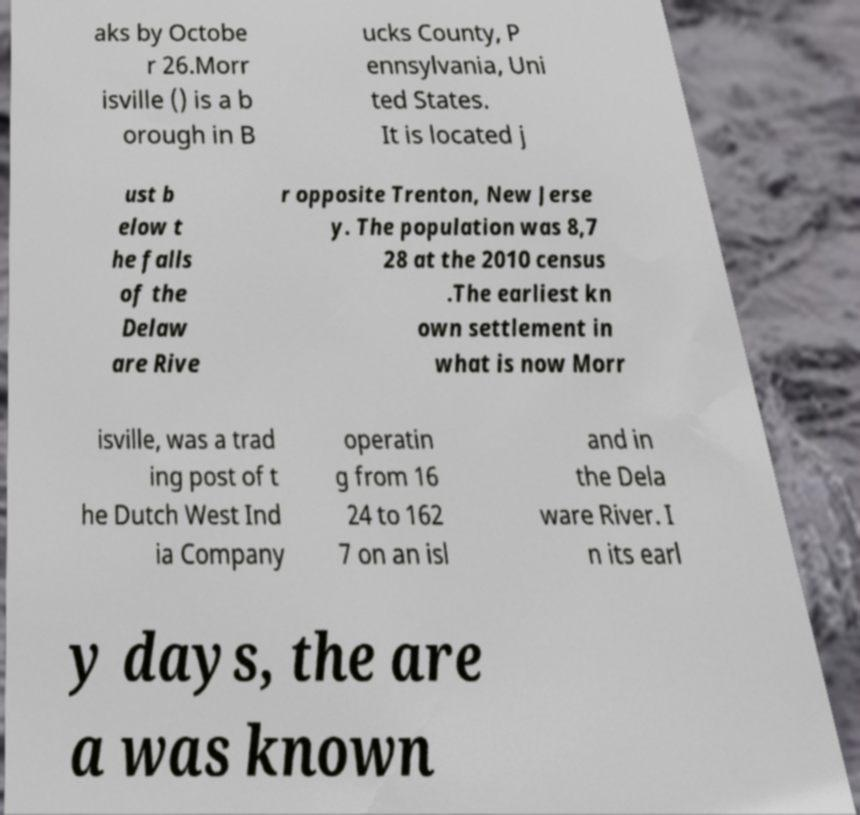Could you assist in decoding the text presented in this image and type it out clearly? aks by Octobe r 26.Morr isville () is a b orough in B ucks County, P ennsylvania, Uni ted States. It is located j ust b elow t he falls of the Delaw are Rive r opposite Trenton, New Jerse y. The population was 8,7 28 at the 2010 census .The earliest kn own settlement in what is now Morr isville, was a trad ing post of t he Dutch West Ind ia Company operatin g from 16 24 to 162 7 on an isl and in the Dela ware River. I n its earl y days, the are a was known 